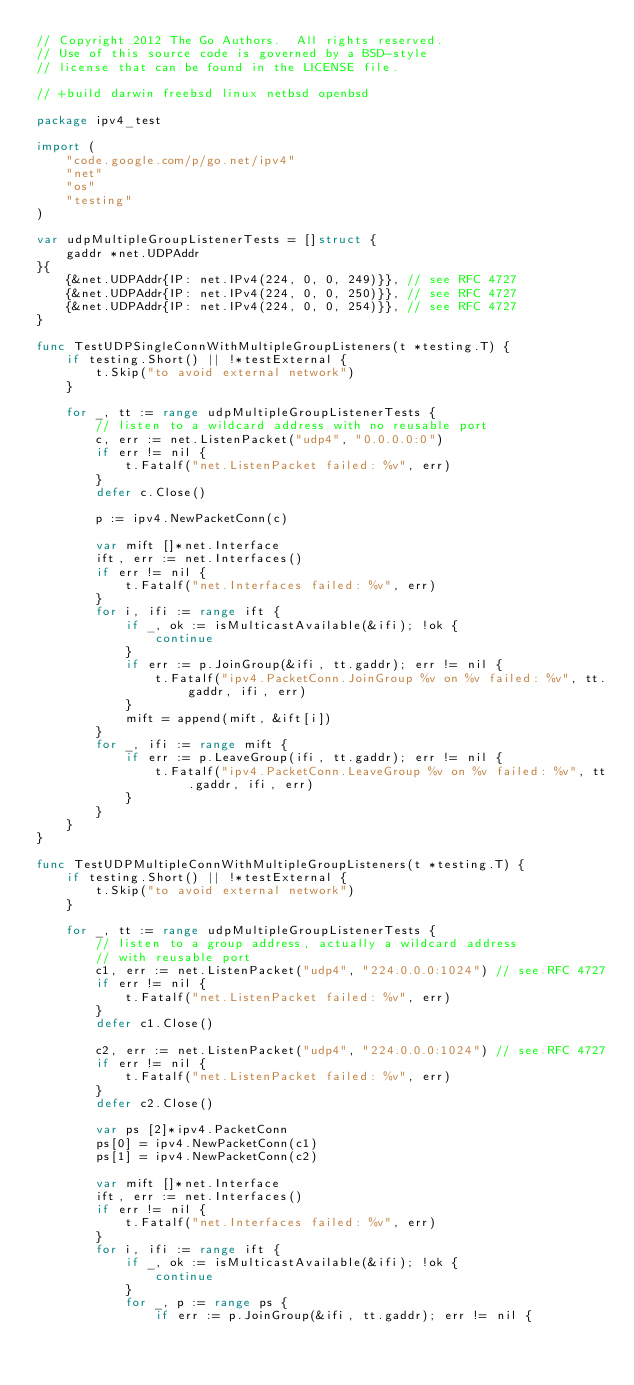<code> <loc_0><loc_0><loc_500><loc_500><_Go_>// Copyright 2012 The Go Authors.  All rights reserved.
// Use of this source code is governed by a BSD-style
// license that can be found in the LICENSE file.

// +build darwin freebsd linux netbsd openbsd

package ipv4_test

import (
	"code.google.com/p/go.net/ipv4"
	"net"
	"os"
	"testing"
)

var udpMultipleGroupListenerTests = []struct {
	gaddr *net.UDPAddr
}{
	{&net.UDPAddr{IP: net.IPv4(224, 0, 0, 249)}}, // see RFC 4727
	{&net.UDPAddr{IP: net.IPv4(224, 0, 0, 250)}}, // see RFC 4727
	{&net.UDPAddr{IP: net.IPv4(224, 0, 0, 254)}}, // see RFC 4727
}

func TestUDPSingleConnWithMultipleGroupListeners(t *testing.T) {
	if testing.Short() || !*testExternal {
		t.Skip("to avoid external network")
	}

	for _, tt := range udpMultipleGroupListenerTests {
		// listen to a wildcard address with no reusable port
		c, err := net.ListenPacket("udp4", "0.0.0.0:0")
		if err != nil {
			t.Fatalf("net.ListenPacket failed: %v", err)
		}
		defer c.Close()

		p := ipv4.NewPacketConn(c)

		var mift []*net.Interface
		ift, err := net.Interfaces()
		if err != nil {
			t.Fatalf("net.Interfaces failed: %v", err)
		}
		for i, ifi := range ift {
			if _, ok := isMulticastAvailable(&ifi); !ok {
				continue
			}
			if err := p.JoinGroup(&ifi, tt.gaddr); err != nil {
				t.Fatalf("ipv4.PacketConn.JoinGroup %v on %v failed: %v", tt.gaddr, ifi, err)
			}
			mift = append(mift, &ift[i])
		}
		for _, ifi := range mift {
			if err := p.LeaveGroup(ifi, tt.gaddr); err != nil {
				t.Fatalf("ipv4.PacketConn.LeaveGroup %v on %v failed: %v", tt.gaddr, ifi, err)
			}
		}
	}
}

func TestUDPMultipleConnWithMultipleGroupListeners(t *testing.T) {
	if testing.Short() || !*testExternal {
		t.Skip("to avoid external network")
	}

	for _, tt := range udpMultipleGroupListenerTests {
		// listen to a group address, actually a wildcard address
		// with reusable port
		c1, err := net.ListenPacket("udp4", "224.0.0.0:1024") // see RFC 4727
		if err != nil {
			t.Fatalf("net.ListenPacket failed: %v", err)
		}
		defer c1.Close()

		c2, err := net.ListenPacket("udp4", "224.0.0.0:1024") // see RFC 4727
		if err != nil {
			t.Fatalf("net.ListenPacket failed: %v", err)
		}
		defer c2.Close()

		var ps [2]*ipv4.PacketConn
		ps[0] = ipv4.NewPacketConn(c1)
		ps[1] = ipv4.NewPacketConn(c2)

		var mift []*net.Interface
		ift, err := net.Interfaces()
		if err != nil {
			t.Fatalf("net.Interfaces failed: %v", err)
		}
		for i, ifi := range ift {
			if _, ok := isMulticastAvailable(&ifi); !ok {
				continue
			}
			for _, p := range ps {
				if err := p.JoinGroup(&ifi, tt.gaddr); err != nil {</code> 